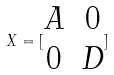Convert formula to latex. <formula><loc_0><loc_0><loc_500><loc_500>X = [ \begin{matrix} A & 0 \\ 0 & D \end{matrix} ]</formula> 